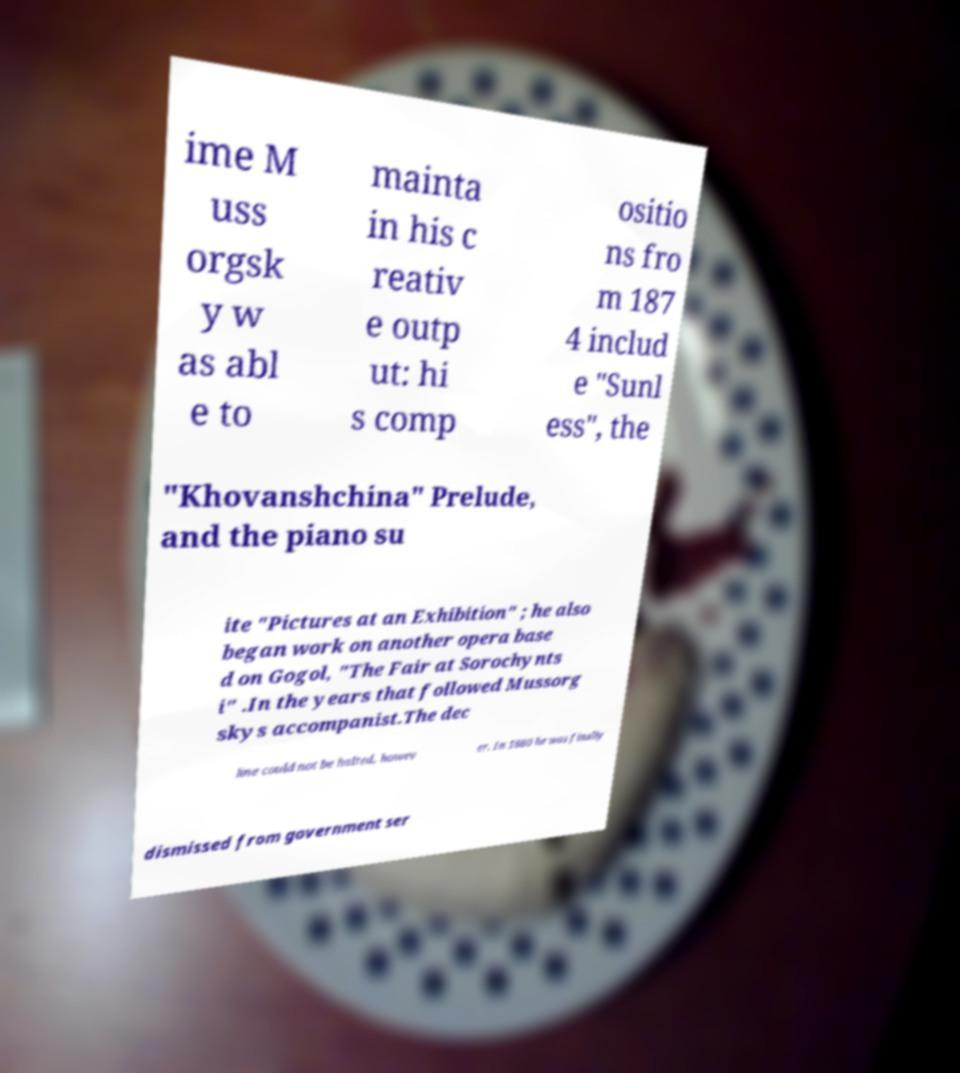There's text embedded in this image that I need extracted. Can you transcribe it verbatim? ime M uss orgsk y w as abl e to mainta in his c reativ e outp ut: hi s comp ositio ns fro m 187 4 includ e "Sunl ess", the "Khovanshchina" Prelude, and the piano su ite "Pictures at an Exhibition" ; he also began work on another opera base d on Gogol, "The Fair at Sorochynts i" .In the years that followed Mussorg skys accompanist.The dec line could not be halted, howev er. In 1880 he was finally dismissed from government ser 